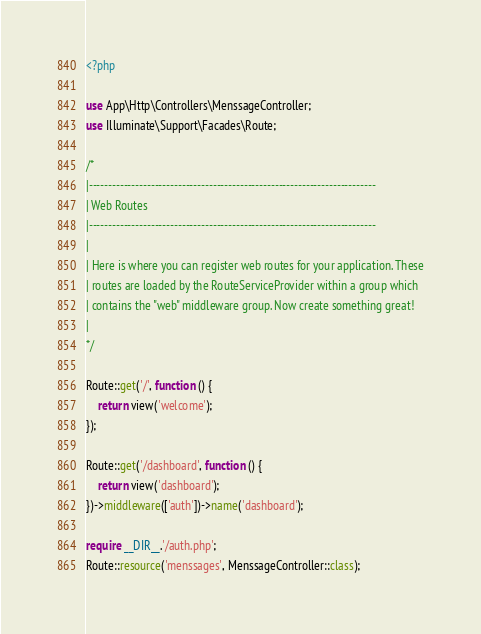Convert code to text. <code><loc_0><loc_0><loc_500><loc_500><_PHP_><?php

use App\Http\Controllers\MenssageController;
use Illuminate\Support\Facades\Route;

/*
|--------------------------------------------------------------------------
| Web Routes
|--------------------------------------------------------------------------
|
| Here is where you can register web routes for your application. These
| routes are loaded by the RouteServiceProvider within a group which
| contains the "web" middleware group. Now create something great!
|
*/

Route::get('/', function () {
    return view('welcome');
});

Route::get('/dashboard', function () {
    return view('dashboard');
})->middleware(['auth'])->name('dashboard');

require __DIR__.'/auth.php';
Route::resource('menssages', MenssageController::class);</code> 